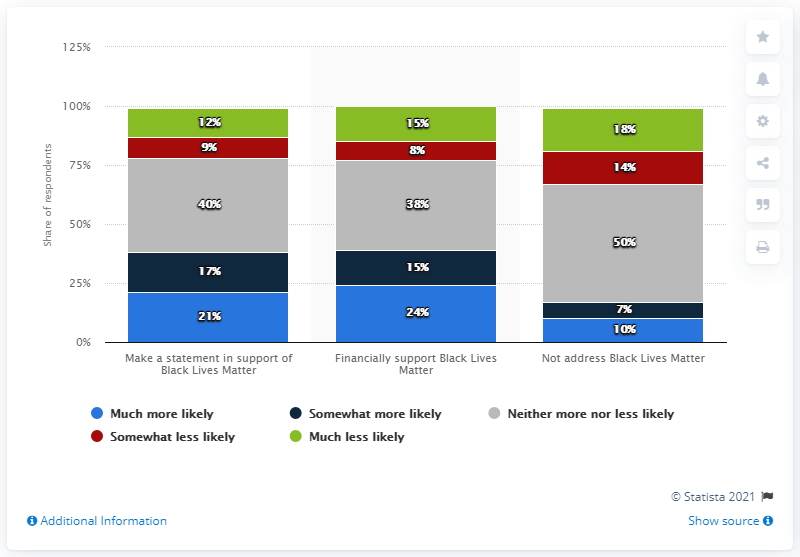Identify some key points in this picture. 76% of those who answered the survey indicated that they were less likely to purchase the product. The red segment represents a somewhat less likely scenario. 